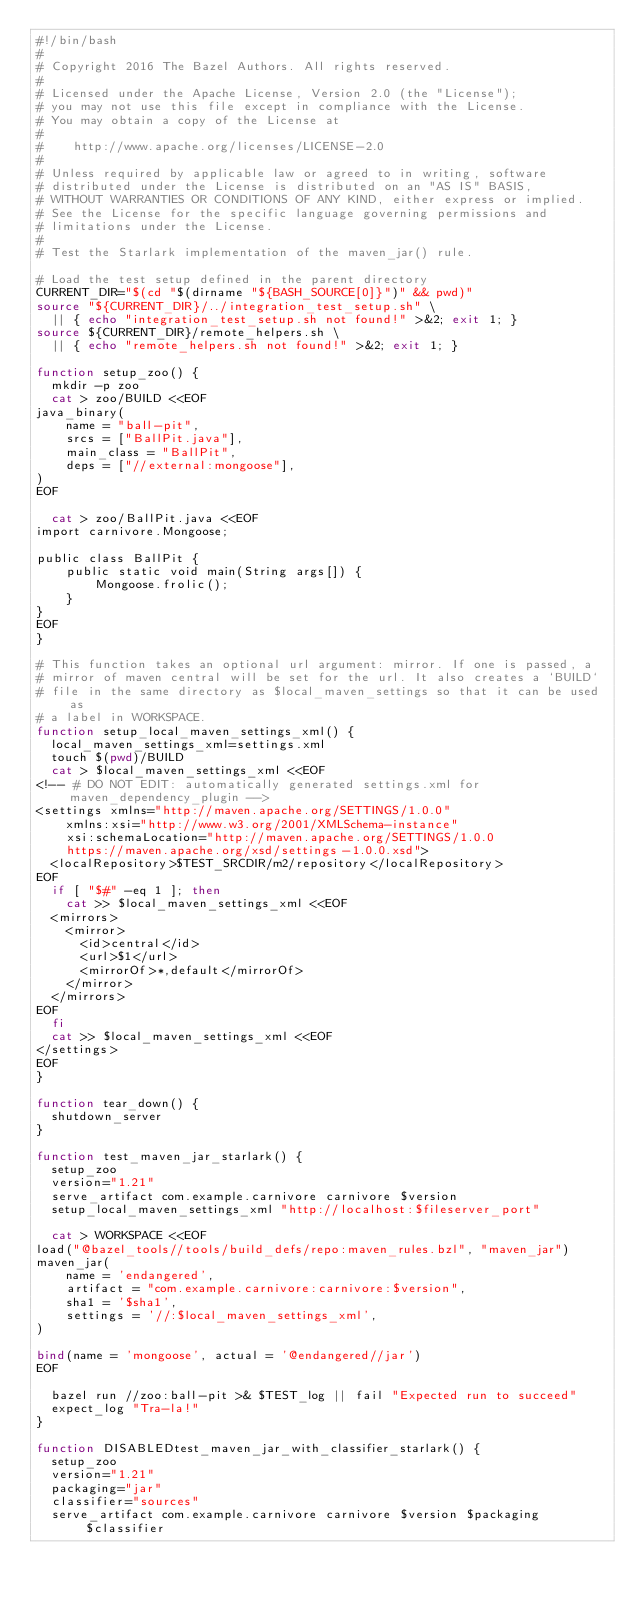<code> <loc_0><loc_0><loc_500><loc_500><_Bash_>#!/bin/bash
#
# Copyright 2016 The Bazel Authors. All rights reserved.
#
# Licensed under the Apache License, Version 2.0 (the "License");
# you may not use this file except in compliance with the License.
# You may obtain a copy of the License at
#
#    http://www.apache.org/licenses/LICENSE-2.0
#
# Unless required by applicable law or agreed to in writing, software
# distributed under the License is distributed on an "AS IS" BASIS,
# WITHOUT WARRANTIES OR CONDITIONS OF ANY KIND, either express or implied.
# See the License for the specific language governing permissions and
# limitations under the License.
#
# Test the Starlark implementation of the maven_jar() rule.

# Load the test setup defined in the parent directory
CURRENT_DIR="$(cd "$(dirname "${BASH_SOURCE[0]}")" && pwd)"
source "${CURRENT_DIR}/../integration_test_setup.sh" \
  || { echo "integration_test_setup.sh not found!" >&2; exit 1; }
source ${CURRENT_DIR}/remote_helpers.sh \
  || { echo "remote_helpers.sh not found!" >&2; exit 1; }

function setup_zoo() {
  mkdir -p zoo
  cat > zoo/BUILD <<EOF
java_binary(
    name = "ball-pit",
    srcs = ["BallPit.java"],
    main_class = "BallPit",
    deps = ["//external:mongoose"],
)
EOF

  cat > zoo/BallPit.java <<EOF
import carnivore.Mongoose;

public class BallPit {
    public static void main(String args[]) {
        Mongoose.frolic();
    }
}
EOF
}

# This function takes an optional url argument: mirror. If one is passed, a
# mirror of maven central will be set for the url. It also creates a `BUILD`
# file in the same directory as $local_maven_settings so that it can be used as
# a label in WORKSPACE.
function setup_local_maven_settings_xml() {
  local_maven_settings_xml=settings.xml
  touch $(pwd)/BUILD
  cat > $local_maven_settings_xml <<EOF
<!-- # DO NOT EDIT: automatically generated settings.xml for maven_dependency_plugin -->
<settings xmlns="http://maven.apache.org/SETTINGS/1.0.0"
    xmlns:xsi="http://www.w3.org/2001/XMLSchema-instance"
    xsi:schemaLocation="http://maven.apache.org/SETTINGS/1.0.0
    https://maven.apache.org/xsd/settings-1.0.0.xsd">
  <localRepository>$TEST_SRCDIR/m2/repository</localRepository>
EOF
  if [ "$#" -eq 1 ]; then
    cat >> $local_maven_settings_xml <<EOF
  <mirrors>
    <mirror>
      <id>central</id>
      <url>$1</url>
      <mirrorOf>*,default</mirrorOf>
    </mirror>
  </mirrors>
EOF
  fi
  cat >> $local_maven_settings_xml <<EOF
</settings>
EOF
}

function tear_down() {
  shutdown_server
}

function test_maven_jar_starlark() {
  setup_zoo
  version="1.21"
  serve_artifact com.example.carnivore carnivore $version
  setup_local_maven_settings_xml "http://localhost:$fileserver_port"

  cat > WORKSPACE <<EOF
load("@bazel_tools//tools/build_defs/repo:maven_rules.bzl", "maven_jar")
maven_jar(
    name = 'endangered',
    artifact = "com.example.carnivore:carnivore:$version",
    sha1 = '$sha1',
    settings = '//:$local_maven_settings_xml',
)

bind(name = 'mongoose', actual = '@endangered//jar')
EOF

  bazel run //zoo:ball-pit >& $TEST_log || fail "Expected run to succeed"
  expect_log "Tra-la!"
}

function DISABLEDtest_maven_jar_with_classifier_starlark() {
  setup_zoo
  version="1.21"
  packaging="jar"
  classifier="sources"
  serve_artifact com.example.carnivore carnivore $version $packaging $classifier</code> 